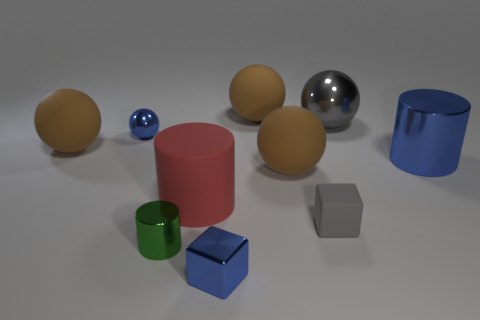How many brown balls must be subtracted to get 1 brown balls? 2 Subtract all red cylinders. How many cylinders are left? 2 Subtract all cylinders. How many objects are left? 7 Subtract all brown cubes. How many brown spheres are left? 3 Subtract all red cylinders. Subtract all yellow balls. How many cylinders are left? 2 Subtract all large blue objects. Subtract all tiny green metallic cylinders. How many objects are left? 8 Add 8 tiny blue balls. How many tiny blue balls are left? 9 Add 6 tiny green things. How many tiny green things exist? 7 Subtract all blue cylinders. How many cylinders are left? 2 Subtract 3 brown spheres. How many objects are left? 7 